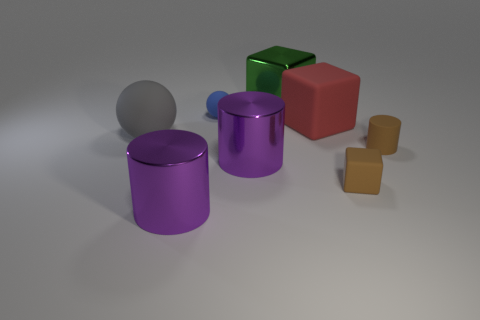Is there a small thing of the same color as the tiny matte cylinder?
Your answer should be compact. Yes. There is a object that is the same color as the tiny cylinder; what size is it?
Your response must be concise. Small. Is the number of small brown blocks on the right side of the blue object greater than the number of tiny cubes?
Provide a short and direct response. No. There is a cylinder that is on the right side of the metal thing behind the tiny brown rubber cylinder; how many objects are in front of it?
Provide a succinct answer. 3. Is the size of the brown cylinder that is in front of the green metal object the same as the red thing that is in front of the green object?
Offer a terse response. No. There is a big cube behind the matte ball that is behind the big red block; what is its material?
Make the answer very short. Metal. What number of objects are tiny rubber things that are to the left of the green cube or big gray balls?
Keep it short and to the point. 2. Are there an equal number of large red matte things behind the big green metallic thing and cylinders that are in front of the brown cylinder?
Your answer should be very brief. No. There is a purple cylinder in front of the purple object behind the metal cylinder on the left side of the small blue sphere; what is it made of?
Your answer should be very brief. Metal. There is a matte thing that is in front of the large rubber cube and to the left of the large red thing; what size is it?
Your answer should be compact. Large. 